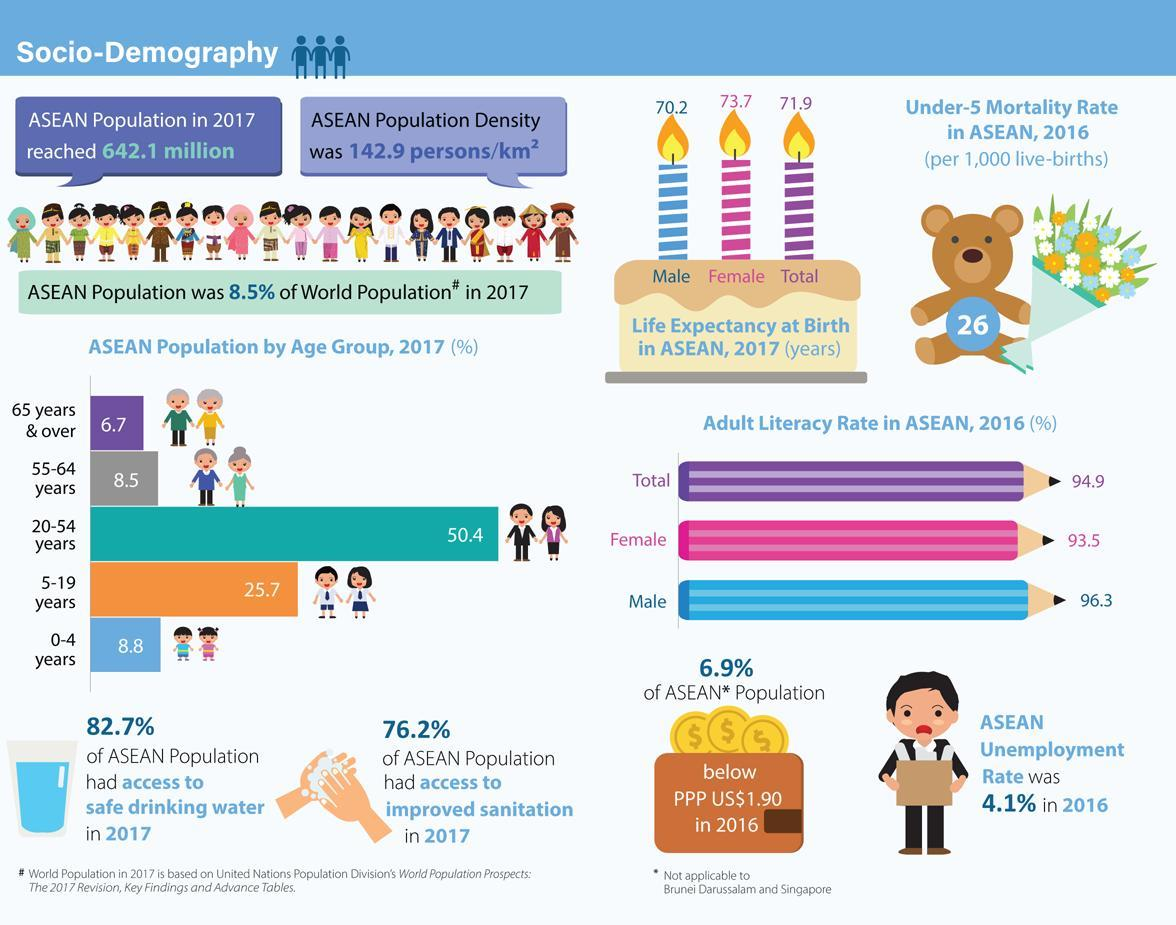What percentage of the ASEAN population had access to safe drinking water in 2017?
Answer the question with a short phrase. 82.7% What is the male expectancy at birth in ASEAN,2017? 70.2 What is the female expectancy at birth in ASEAN,2017? 73.7 What percentage of the ASEAN population had access to improved sanitation in 2017? 76.2% What is the adult literacy rate of females and males, taken together? 189.8 